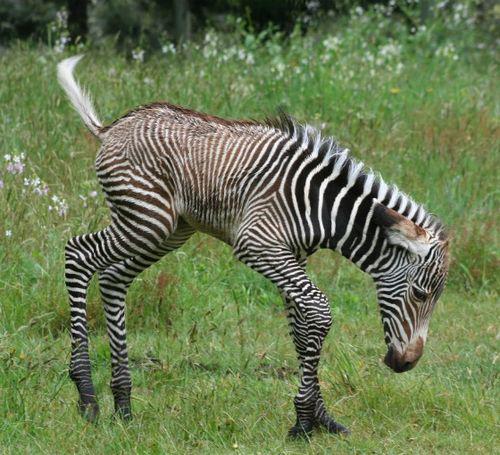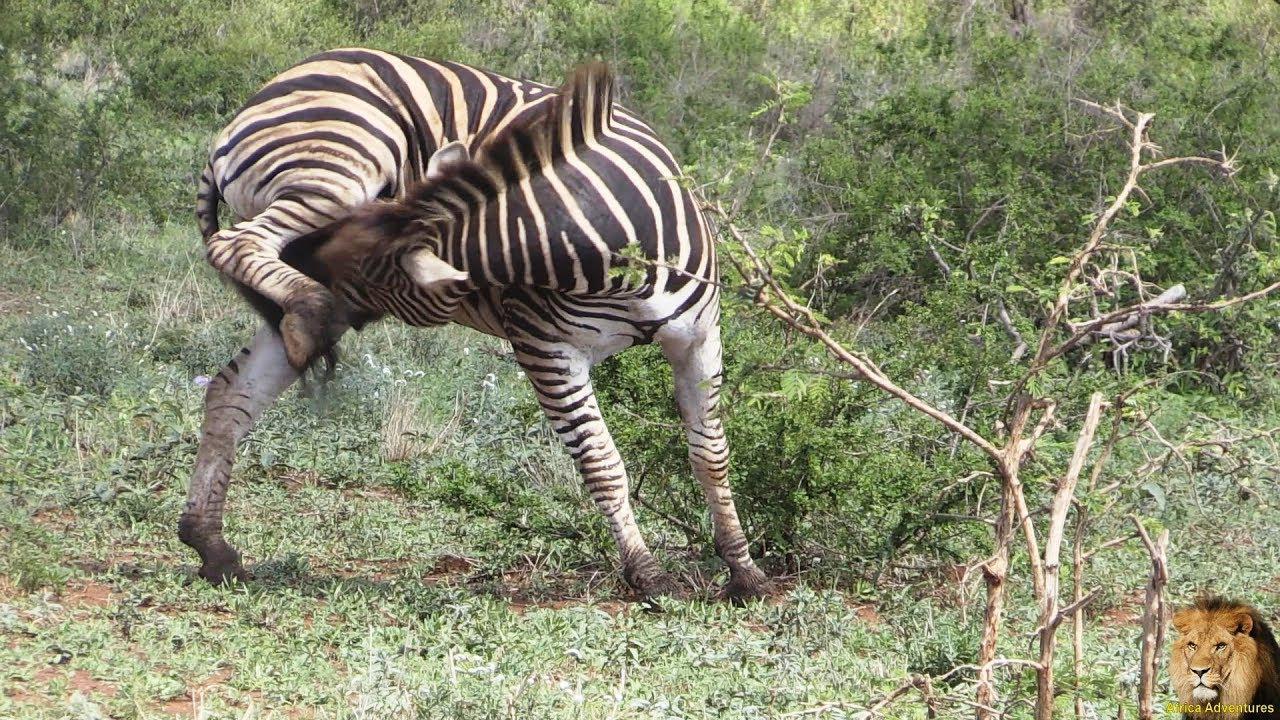The first image is the image on the left, the second image is the image on the right. Given the left and right images, does the statement "Fewer than 3 Zebras total." hold true? Answer yes or no. Yes. 